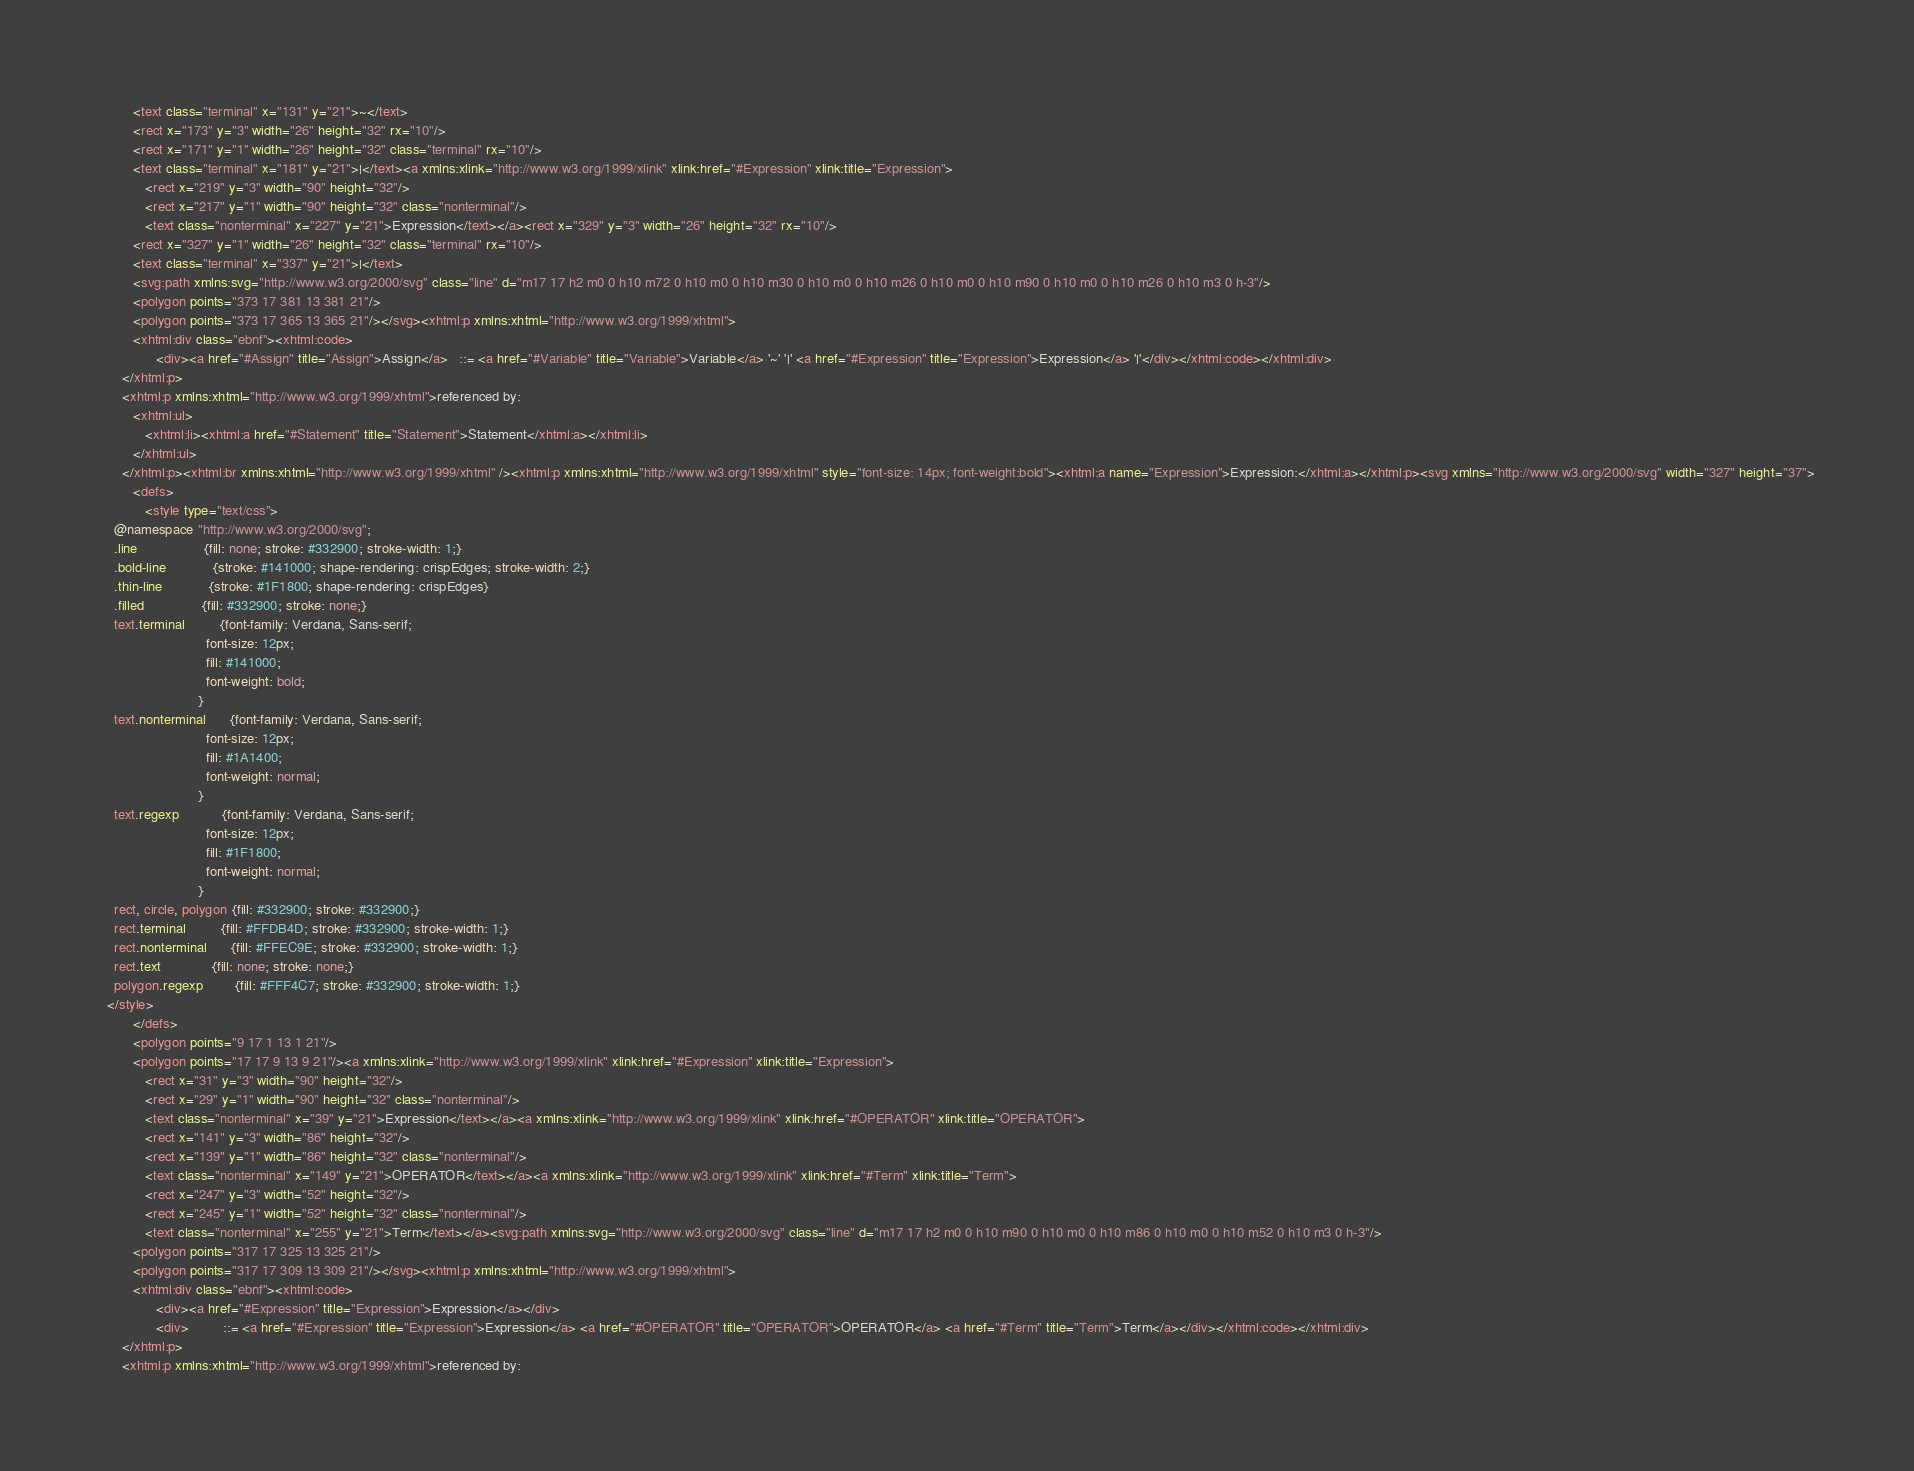Convert code to text. <code><loc_0><loc_0><loc_500><loc_500><_HTML_>         <text class="terminal" x="131" y="21">~</text>
         <rect x="173" y="3" width="26" height="32" rx="10"/>
         <rect x="171" y="1" width="26" height="32" class="terminal" rx="10"/>
         <text class="terminal" x="181" y="21">|</text><a xmlns:xlink="http://www.w3.org/1999/xlink" xlink:href="#Expression" xlink:title="Expression">
            <rect x="219" y="3" width="90" height="32"/>
            <rect x="217" y="1" width="90" height="32" class="nonterminal"/>
            <text class="nonterminal" x="227" y="21">Expression</text></a><rect x="329" y="3" width="26" height="32" rx="10"/>
         <rect x="327" y="1" width="26" height="32" class="terminal" rx="10"/>
         <text class="terminal" x="337" y="21">|</text>
         <svg:path xmlns:svg="http://www.w3.org/2000/svg" class="line" d="m17 17 h2 m0 0 h10 m72 0 h10 m0 0 h10 m30 0 h10 m0 0 h10 m26 0 h10 m0 0 h10 m90 0 h10 m0 0 h10 m26 0 h10 m3 0 h-3"/>
         <polygon points="373 17 381 13 381 21"/>
         <polygon points="373 17 365 13 365 21"/></svg><xhtml:p xmlns:xhtml="http://www.w3.org/1999/xhtml">
         <xhtml:div class="ebnf"><xhtml:code>
               <div><a href="#Assign" title="Assign">Assign</a>   ::= <a href="#Variable" title="Variable">Variable</a> '~' '|' <a href="#Expression" title="Expression">Expression</a> '|'</div></xhtml:code></xhtml:div>
      </xhtml:p>
      <xhtml:p xmlns:xhtml="http://www.w3.org/1999/xhtml">referenced by:
         <xhtml:ul>
            <xhtml:li><xhtml:a href="#Statement" title="Statement">Statement</xhtml:a></xhtml:li>
         </xhtml:ul>
      </xhtml:p><xhtml:br xmlns:xhtml="http://www.w3.org/1999/xhtml" /><xhtml:p xmlns:xhtml="http://www.w3.org/1999/xhtml" style="font-size: 14px; font-weight:bold"><xhtml:a name="Expression">Expression:</xhtml:a></xhtml:p><svg xmlns="http://www.w3.org/2000/svg" width="327" height="37">
         <defs>
            <style type="text/css">
    @namespace "http://www.w3.org/2000/svg";
    .line                 {fill: none; stroke: #332900; stroke-width: 1;}
    .bold-line            {stroke: #141000; shape-rendering: crispEdges; stroke-width: 2;}
    .thin-line            {stroke: #1F1800; shape-rendering: crispEdges}
    .filled               {fill: #332900; stroke: none;}
    text.terminal         {font-family: Verdana, Sans-serif;
                            font-size: 12px;
                            fill: #141000;
                            font-weight: bold;
                          }
    text.nonterminal      {font-family: Verdana, Sans-serif;
                            font-size: 12px;
                            fill: #1A1400;
                            font-weight: normal;
                          }
    text.regexp           {font-family: Verdana, Sans-serif;
                            font-size: 12px;
                            fill: #1F1800;
                            font-weight: normal;
                          }
    rect, circle, polygon {fill: #332900; stroke: #332900;}
    rect.terminal         {fill: #FFDB4D; stroke: #332900; stroke-width: 1;}
    rect.nonterminal      {fill: #FFEC9E; stroke: #332900; stroke-width: 1;}
    rect.text             {fill: none; stroke: none;}
    polygon.regexp        {fill: #FFF4C7; stroke: #332900; stroke-width: 1;}
  </style>
         </defs>
         <polygon points="9 17 1 13 1 21"/>
         <polygon points="17 17 9 13 9 21"/><a xmlns:xlink="http://www.w3.org/1999/xlink" xlink:href="#Expression" xlink:title="Expression">
            <rect x="31" y="3" width="90" height="32"/>
            <rect x="29" y="1" width="90" height="32" class="nonterminal"/>
            <text class="nonterminal" x="39" y="21">Expression</text></a><a xmlns:xlink="http://www.w3.org/1999/xlink" xlink:href="#OPERATOR" xlink:title="OPERATOR">
            <rect x="141" y="3" width="86" height="32"/>
            <rect x="139" y="1" width="86" height="32" class="nonterminal"/>
            <text class="nonterminal" x="149" y="21">OPERATOR</text></a><a xmlns:xlink="http://www.w3.org/1999/xlink" xlink:href="#Term" xlink:title="Term">
            <rect x="247" y="3" width="52" height="32"/>
            <rect x="245" y="1" width="52" height="32" class="nonterminal"/>
            <text class="nonterminal" x="255" y="21">Term</text></a><svg:path xmlns:svg="http://www.w3.org/2000/svg" class="line" d="m17 17 h2 m0 0 h10 m90 0 h10 m0 0 h10 m86 0 h10 m0 0 h10 m52 0 h10 m3 0 h-3"/>
         <polygon points="317 17 325 13 325 21"/>
         <polygon points="317 17 309 13 309 21"/></svg><xhtml:p xmlns:xhtml="http://www.w3.org/1999/xhtml">
         <xhtml:div class="ebnf"><xhtml:code>
               <div><a href="#Expression" title="Expression">Expression</a></div>
               <div>         ::= <a href="#Expression" title="Expression">Expression</a> <a href="#OPERATOR" title="OPERATOR">OPERATOR</a> <a href="#Term" title="Term">Term</a></div></xhtml:code></xhtml:div>
      </xhtml:p>
      <xhtml:p xmlns:xhtml="http://www.w3.org/1999/xhtml">referenced by:</code> 